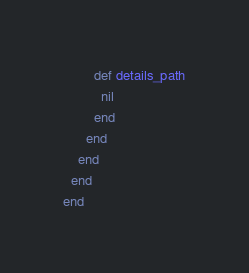Convert code to text. <code><loc_0><loc_0><loc_500><loc_500><_Ruby_>
        def details_path
          nil
        end
      end
    end
  end
end
</code> 